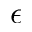Convert formula to latex. <formula><loc_0><loc_0><loc_500><loc_500>\epsilon</formula> 